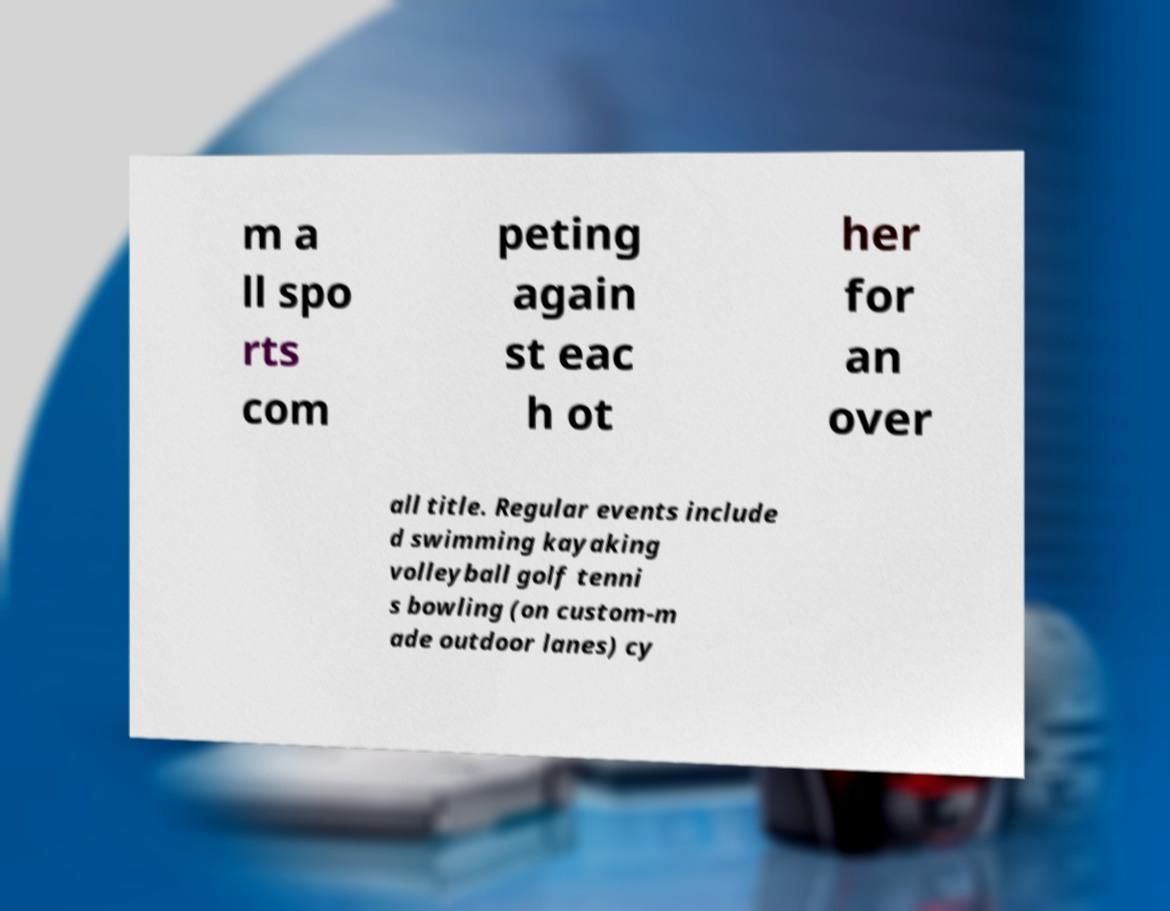Could you assist in decoding the text presented in this image and type it out clearly? m a ll spo rts com peting again st eac h ot her for an over all title. Regular events include d swimming kayaking volleyball golf tenni s bowling (on custom-m ade outdoor lanes) cy 